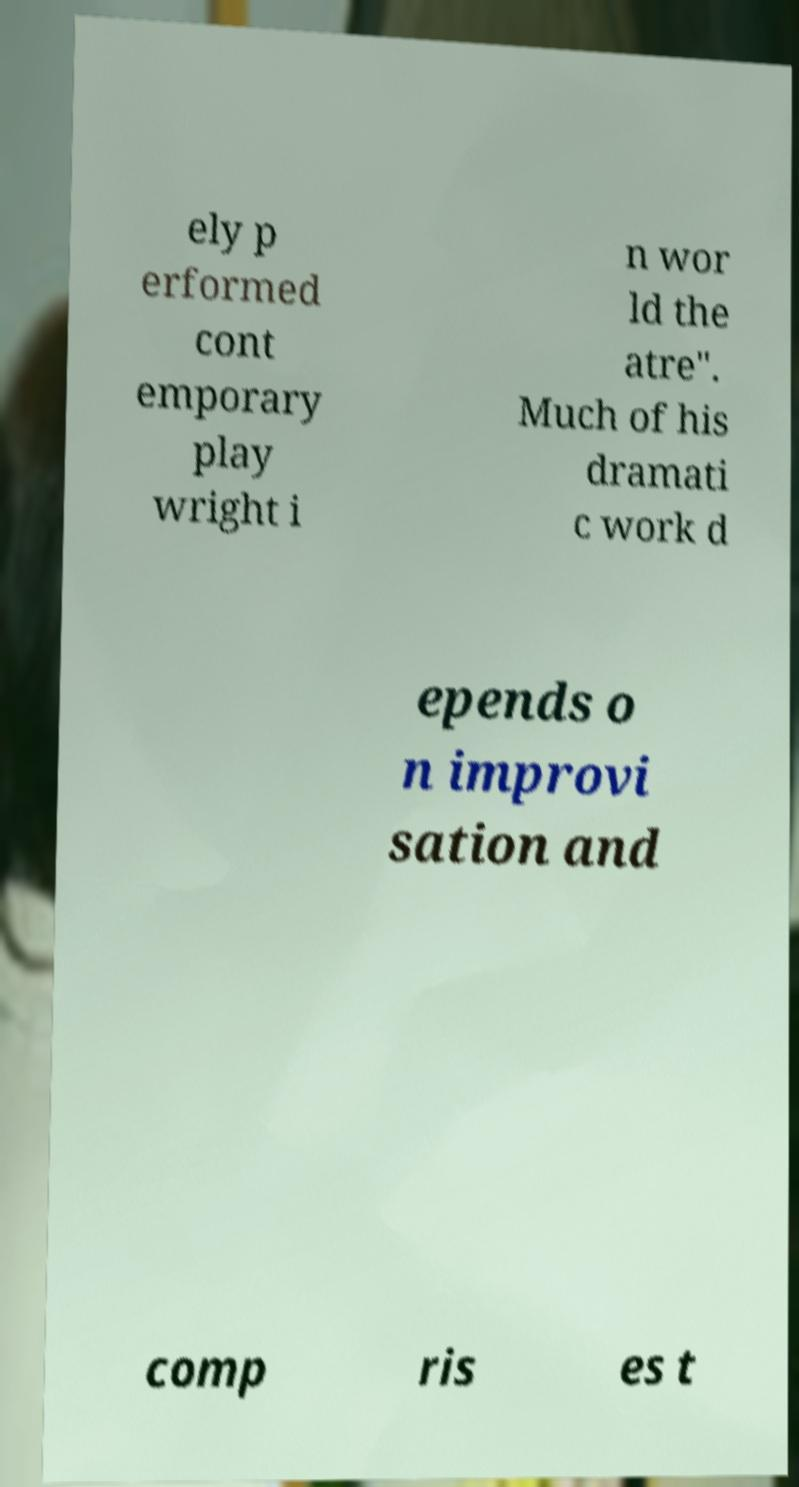What messages or text are displayed in this image? I need them in a readable, typed format. ely p erformed cont emporary play wright i n wor ld the atre". Much of his dramati c work d epends o n improvi sation and comp ris es t 